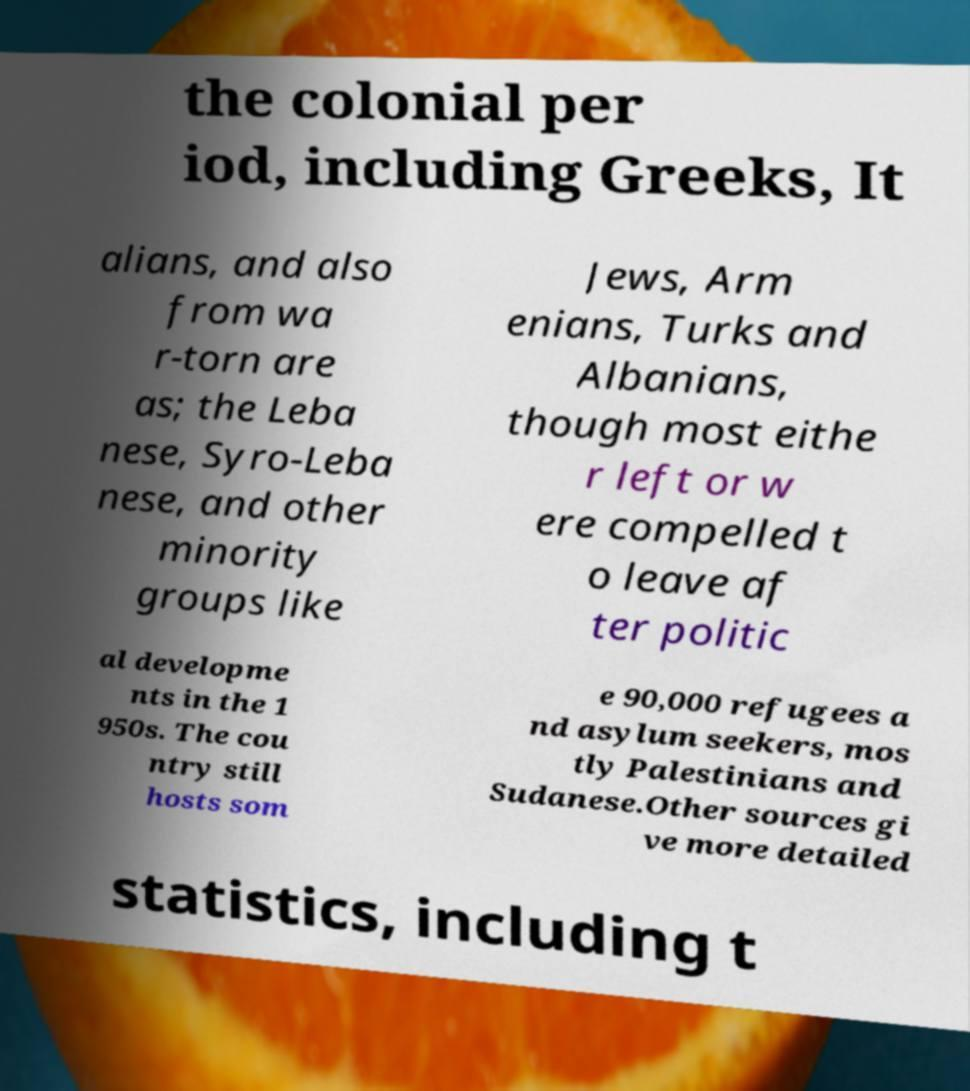Can you accurately transcribe the text from the provided image for me? the colonial per iod, including Greeks, It alians, and also from wa r-torn are as; the Leba nese, Syro-Leba nese, and other minority groups like Jews, Arm enians, Turks and Albanians, though most eithe r left or w ere compelled t o leave af ter politic al developme nts in the 1 950s. The cou ntry still hosts som e 90,000 refugees a nd asylum seekers, mos tly Palestinians and Sudanese.Other sources gi ve more detailed statistics, including t 